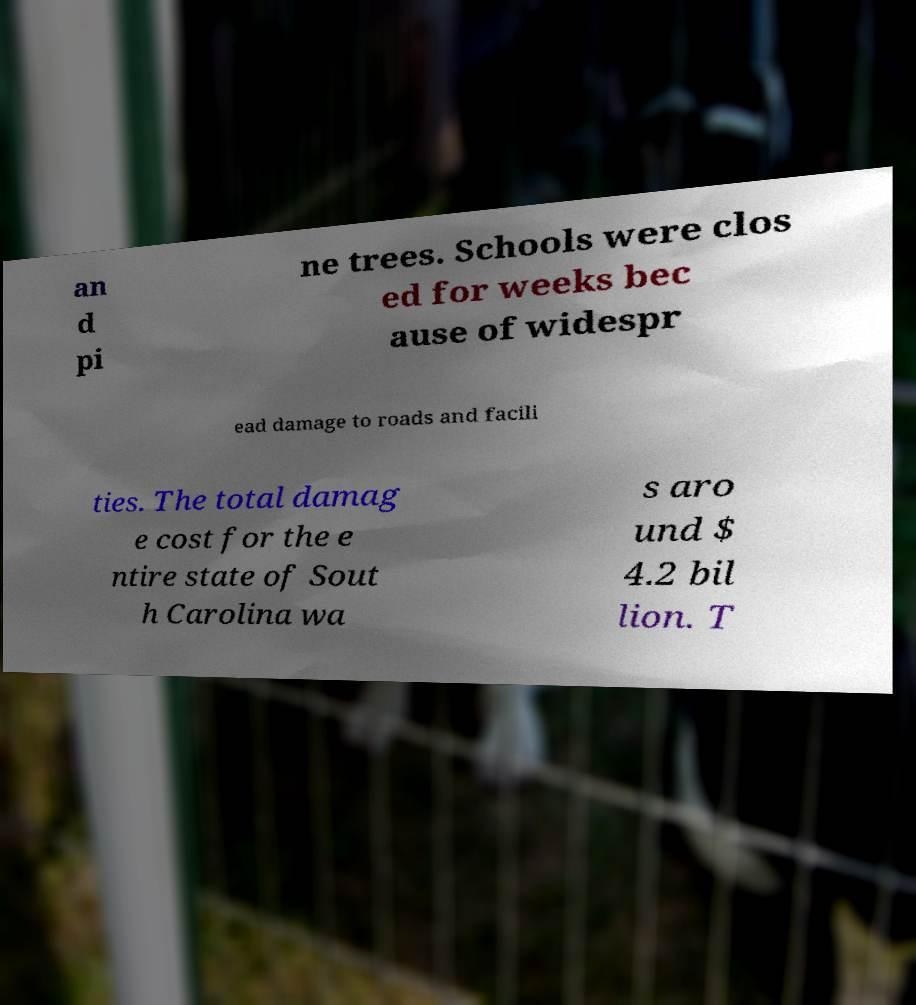What messages or text are displayed in this image? I need them in a readable, typed format. an d pi ne trees. Schools were clos ed for weeks bec ause of widespr ead damage to roads and facili ties. The total damag e cost for the e ntire state of Sout h Carolina wa s aro und $ 4.2 bil lion. T 